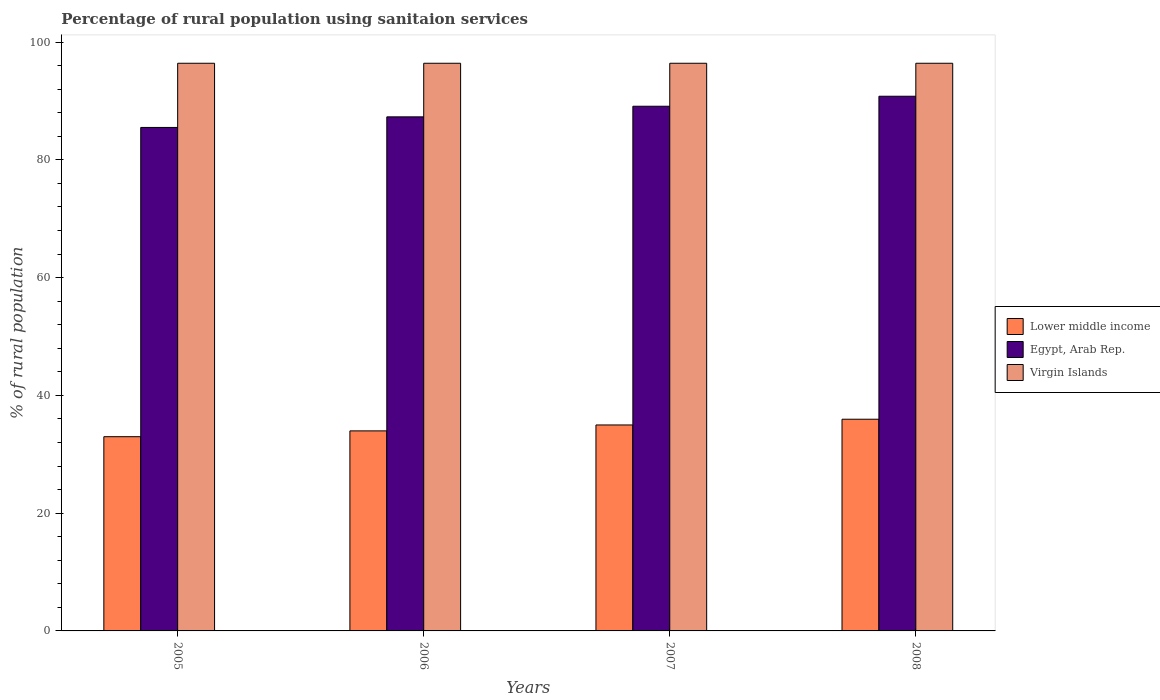How many different coloured bars are there?
Provide a short and direct response. 3. How many groups of bars are there?
Your response must be concise. 4. Are the number of bars on each tick of the X-axis equal?
Give a very brief answer. Yes. How many bars are there on the 2nd tick from the right?
Provide a short and direct response. 3. What is the label of the 2nd group of bars from the left?
Your answer should be very brief. 2006. In how many cases, is the number of bars for a given year not equal to the number of legend labels?
Ensure brevity in your answer.  0. What is the percentage of rural population using sanitaion services in Lower middle income in 2007?
Provide a succinct answer. 34.98. Across all years, what is the maximum percentage of rural population using sanitaion services in Lower middle income?
Provide a short and direct response. 35.95. Across all years, what is the minimum percentage of rural population using sanitaion services in Virgin Islands?
Your response must be concise. 96.4. What is the total percentage of rural population using sanitaion services in Lower middle income in the graph?
Ensure brevity in your answer.  137.88. What is the difference between the percentage of rural population using sanitaion services in Egypt, Arab Rep. in 2006 and that in 2007?
Ensure brevity in your answer.  -1.8. What is the difference between the percentage of rural population using sanitaion services in Egypt, Arab Rep. in 2007 and the percentage of rural population using sanitaion services in Virgin Islands in 2005?
Offer a very short reply. -7.3. What is the average percentage of rural population using sanitaion services in Lower middle income per year?
Offer a terse response. 34.47. In the year 2006, what is the difference between the percentage of rural population using sanitaion services in Lower middle income and percentage of rural population using sanitaion services in Egypt, Arab Rep.?
Make the answer very short. -53.33. What is the ratio of the percentage of rural population using sanitaion services in Egypt, Arab Rep. in 2006 to that in 2008?
Your response must be concise. 0.96. Is the percentage of rural population using sanitaion services in Lower middle income in 2005 less than that in 2007?
Ensure brevity in your answer.  Yes. Is the difference between the percentage of rural population using sanitaion services in Lower middle income in 2007 and 2008 greater than the difference between the percentage of rural population using sanitaion services in Egypt, Arab Rep. in 2007 and 2008?
Your answer should be compact. Yes. What is the difference between the highest and the second highest percentage of rural population using sanitaion services in Lower middle income?
Your answer should be compact. 0.97. What is the difference between the highest and the lowest percentage of rural population using sanitaion services in Virgin Islands?
Make the answer very short. 0. In how many years, is the percentage of rural population using sanitaion services in Egypt, Arab Rep. greater than the average percentage of rural population using sanitaion services in Egypt, Arab Rep. taken over all years?
Make the answer very short. 2. What does the 1st bar from the left in 2005 represents?
Give a very brief answer. Lower middle income. What does the 1st bar from the right in 2008 represents?
Your answer should be compact. Virgin Islands. How many years are there in the graph?
Offer a very short reply. 4. Are the values on the major ticks of Y-axis written in scientific E-notation?
Your answer should be very brief. No. Does the graph contain grids?
Keep it short and to the point. No. What is the title of the graph?
Your answer should be compact. Percentage of rural population using sanitaion services. Does "Bhutan" appear as one of the legend labels in the graph?
Your answer should be very brief. No. What is the label or title of the Y-axis?
Provide a succinct answer. % of rural population. What is the % of rural population of Lower middle income in 2005?
Your answer should be very brief. 32.98. What is the % of rural population in Egypt, Arab Rep. in 2005?
Provide a succinct answer. 85.5. What is the % of rural population of Virgin Islands in 2005?
Provide a succinct answer. 96.4. What is the % of rural population in Lower middle income in 2006?
Provide a short and direct response. 33.97. What is the % of rural population in Egypt, Arab Rep. in 2006?
Give a very brief answer. 87.3. What is the % of rural population of Virgin Islands in 2006?
Offer a terse response. 96.4. What is the % of rural population of Lower middle income in 2007?
Your answer should be very brief. 34.98. What is the % of rural population in Egypt, Arab Rep. in 2007?
Keep it short and to the point. 89.1. What is the % of rural population of Virgin Islands in 2007?
Give a very brief answer. 96.4. What is the % of rural population of Lower middle income in 2008?
Provide a short and direct response. 35.95. What is the % of rural population in Egypt, Arab Rep. in 2008?
Make the answer very short. 90.8. What is the % of rural population in Virgin Islands in 2008?
Give a very brief answer. 96.4. Across all years, what is the maximum % of rural population in Lower middle income?
Your answer should be compact. 35.95. Across all years, what is the maximum % of rural population of Egypt, Arab Rep.?
Give a very brief answer. 90.8. Across all years, what is the maximum % of rural population in Virgin Islands?
Give a very brief answer. 96.4. Across all years, what is the minimum % of rural population of Lower middle income?
Offer a terse response. 32.98. Across all years, what is the minimum % of rural population in Egypt, Arab Rep.?
Make the answer very short. 85.5. Across all years, what is the minimum % of rural population in Virgin Islands?
Keep it short and to the point. 96.4. What is the total % of rural population of Lower middle income in the graph?
Your answer should be very brief. 137.88. What is the total % of rural population of Egypt, Arab Rep. in the graph?
Offer a terse response. 352.7. What is the total % of rural population in Virgin Islands in the graph?
Provide a short and direct response. 385.6. What is the difference between the % of rural population in Lower middle income in 2005 and that in 2006?
Your response must be concise. -0.99. What is the difference between the % of rural population of Virgin Islands in 2005 and that in 2006?
Keep it short and to the point. 0. What is the difference between the % of rural population in Lower middle income in 2005 and that in 2007?
Ensure brevity in your answer.  -1.99. What is the difference between the % of rural population of Lower middle income in 2005 and that in 2008?
Keep it short and to the point. -2.97. What is the difference between the % of rural population in Virgin Islands in 2005 and that in 2008?
Make the answer very short. 0. What is the difference between the % of rural population of Lower middle income in 2006 and that in 2007?
Your answer should be very brief. -1.01. What is the difference between the % of rural population in Egypt, Arab Rep. in 2006 and that in 2007?
Give a very brief answer. -1.8. What is the difference between the % of rural population in Lower middle income in 2006 and that in 2008?
Your answer should be compact. -1.98. What is the difference between the % of rural population in Egypt, Arab Rep. in 2006 and that in 2008?
Make the answer very short. -3.5. What is the difference between the % of rural population in Virgin Islands in 2006 and that in 2008?
Your answer should be compact. 0. What is the difference between the % of rural population of Lower middle income in 2007 and that in 2008?
Offer a terse response. -0.97. What is the difference between the % of rural population of Egypt, Arab Rep. in 2007 and that in 2008?
Offer a terse response. -1.7. What is the difference between the % of rural population of Virgin Islands in 2007 and that in 2008?
Provide a succinct answer. 0. What is the difference between the % of rural population of Lower middle income in 2005 and the % of rural population of Egypt, Arab Rep. in 2006?
Offer a very short reply. -54.32. What is the difference between the % of rural population of Lower middle income in 2005 and the % of rural population of Virgin Islands in 2006?
Ensure brevity in your answer.  -63.42. What is the difference between the % of rural population of Lower middle income in 2005 and the % of rural population of Egypt, Arab Rep. in 2007?
Keep it short and to the point. -56.12. What is the difference between the % of rural population of Lower middle income in 2005 and the % of rural population of Virgin Islands in 2007?
Your response must be concise. -63.42. What is the difference between the % of rural population in Egypt, Arab Rep. in 2005 and the % of rural population in Virgin Islands in 2007?
Provide a short and direct response. -10.9. What is the difference between the % of rural population in Lower middle income in 2005 and the % of rural population in Egypt, Arab Rep. in 2008?
Provide a short and direct response. -57.82. What is the difference between the % of rural population in Lower middle income in 2005 and the % of rural population in Virgin Islands in 2008?
Your response must be concise. -63.42. What is the difference between the % of rural population in Egypt, Arab Rep. in 2005 and the % of rural population in Virgin Islands in 2008?
Give a very brief answer. -10.9. What is the difference between the % of rural population in Lower middle income in 2006 and the % of rural population in Egypt, Arab Rep. in 2007?
Provide a succinct answer. -55.13. What is the difference between the % of rural population in Lower middle income in 2006 and the % of rural population in Virgin Islands in 2007?
Offer a terse response. -62.43. What is the difference between the % of rural population in Egypt, Arab Rep. in 2006 and the % of rural population in Virgin Islands in 2007?
Keep it short and to the point. -9.1. What is the difference between the % of rural population in Lower middle income in 2006 and the % of rural population in Egypt, Arab Rep. in 2008?
Your answer should be very brief. -56.83. What is the difference between the % of rural population of Lower middle income in 2006 and the % of rural population of Virgin Islands in 2008?
Give a very brief answer. -62.43. What is the difference between the % of rural population of Egypt, Arab Rep. in 2006 and the % of rural population of Virgin Islands in 2008?
Ensure brevity in your answer.  -9.1. What is the difference between the % of rural population of Lower middle income in 2007 and the % of rural population of Egypt, Arab Rep. in 2008?
Your answer should be very brief. -55.82. What is the difference between the % of rural population of Lower middle income in 2007 and the % of rural population of Virgin Islands in 2008?
Provide a short and direct response. -61.42. What is the average % of rural population in Lower middle income per year?
Your response must be concise. 34.47. What is the average % of rural population of Egypt, Arab Rep. per year?
Give a very brief answer. 88.17. What is the average % of rural population in Virgin Islands per year?
Ensure brevity in your answer.  96.4. In the year 2005, what is the difference between the % of rural population in Lower middle income and % of rural population in Egypt, Arab Rep.?
Provide a succinct answer. -52.52. In the year 2005, what is the difference between the % of rural population in Lower middle income and % of rural population in Virgin Islands?
Provide a succinct answer. -63.42. In the year 2006, what is the difference between the % of rural population of Lower middle income and % of rural population of Egypt, Arab Rep.?
Give a very brief answer. -53.33. In the year 2006, what is the difference between the % of rural population of Lower middle income and % of rural population of Virgin Islands?
Your response must be concise. -62.43. In the year 2007, what is the difference between the % of rural population of Lower middle income and % of rural population of Egypt, Arab Rep.?
Your answer should be compact. -54.12. In the year 2007, what is the difference between the % of rural population of Lower middle income and % of rural population of Virgin Islands?
Keep it short and to the point. -61.42. In the year 2008, what is the difference between the % of rural population in Lower middle income and % of rural population in Egypt, Arab Rep.?
Offer a terse response. -54.85. In the year 2008, what is the difference between the % of rural population in Lower middle income and % of rural population in Virgin Islands?
Make the answer very short. -60.45. In the year 2008, what is the difference between the % of rural population of Egypt, Arab Rep. and % of rural population of Virgin Islands?
Your answer should be compact. -5.6. What is the ratio of the % of rural population of Egypt, Arab Rep. in 2005 to that in 2006?
Your answer should be compact. 0.98. What is the ratio of the % of rural population of Lower middle income in 2005 to that in 2007?
Offer a terse response. 0.94. What is the ratio of the % of rural population in Egypt, Arab Rep. in 2005 to that in 2007?
Provide a short and direct response. 0.96. What is the ratio of the % of rural population of Lower middle income in 2005 to that in 2008?
Give a very brief answer. 0.92. What is the ratio of the % of rural population in Egypt, Arab Rep. in 2005 to that in 2008?
Your answer should be compact. 0.94. What is the ratio of the % of rural population of Lower middle income in 2006 to that in 2007?
Your answer should be compact. 0.97. What is the ratio of the % of rural population in Egypt, Arab Rep. in 2006 to that in 2007?
Your answer should be compact. 0.98. What is the ratio of the % of rural population of Lower middle income in 2006 to that in 2008?
Offer a very short reply. 0.94. What is the ratio of the % of rural population of Egypt, Arab Rep. in 2006 to that in 2008?
Provide a succinct answer. 0.96. What is the ratio of the % of rural population in Lower middle income in 2007 to that in 2008?
Offer a terse response. 0.97. What is the ratio of the % of rural population of Egypt, Arab Rep. in 2007 to that in 2008?
Make the answer very short. 0.98. What is the ratio of the % of rural population of Virgin Islands in 2007 to that in 2008?
Offer a terse response. 1. What is the difference between the highest and the second highest % of rural population of Lower middle income?
Offer a very short reply. 0.97. What is the difference between the highest and the second highest % of rural population of Egypt, Arab Rep.?
Offer a very short reply. 1.7. What is the difference between the highest and the lowest % of rural population of Lower middle income?
Offer a very short reply. 2.97. What is the difference between the highest and the lowest % of rural population in Virgin Islands?
Give a very brief answer. 0. 